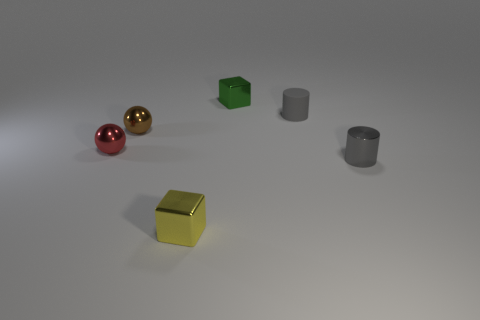Is there a yellow metallic cube that has the same size as the gray metal cylinder?
Provide a succinct answer. Yes. What color is the small cylinder that is the same material as the tiny green cube?
Offer a very short reply. Gray. Is the number of small green things less than the number of small purple blocks?
Ensure brevity in your answer.  No. There is a thing that is both on the right side of the brown ball and on the left side of the green object; what material is it?
Keep it short and to the point. Metal. There is a metal object that is on the right side of the small green shiny block; are there any tiny red metal things on the right side of it?
Keep it short and to the point. No. What number of metallic balls are the same color as the matte object?
Your answer should be compact. 0. What is the material of the other small cylinder that is the same color as the small metallic cylinder?
Keep it short and to the point. Rubber. Are there any green metal blocks behind the yellow block?
Ensure brevity in your answer.  Yes. What is the material of the gray cylinder behind the tiny gray object in front of the tiny rubber cylinder?
Offer a terse response. Rubber. Is the color of the metal cylinder the same as the rubber cylinder?
Your answer should be very brief. Yes. 